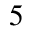<formula> <loc_0><loc_0><loc_500><loc_500>^ { 5 }</formula> 